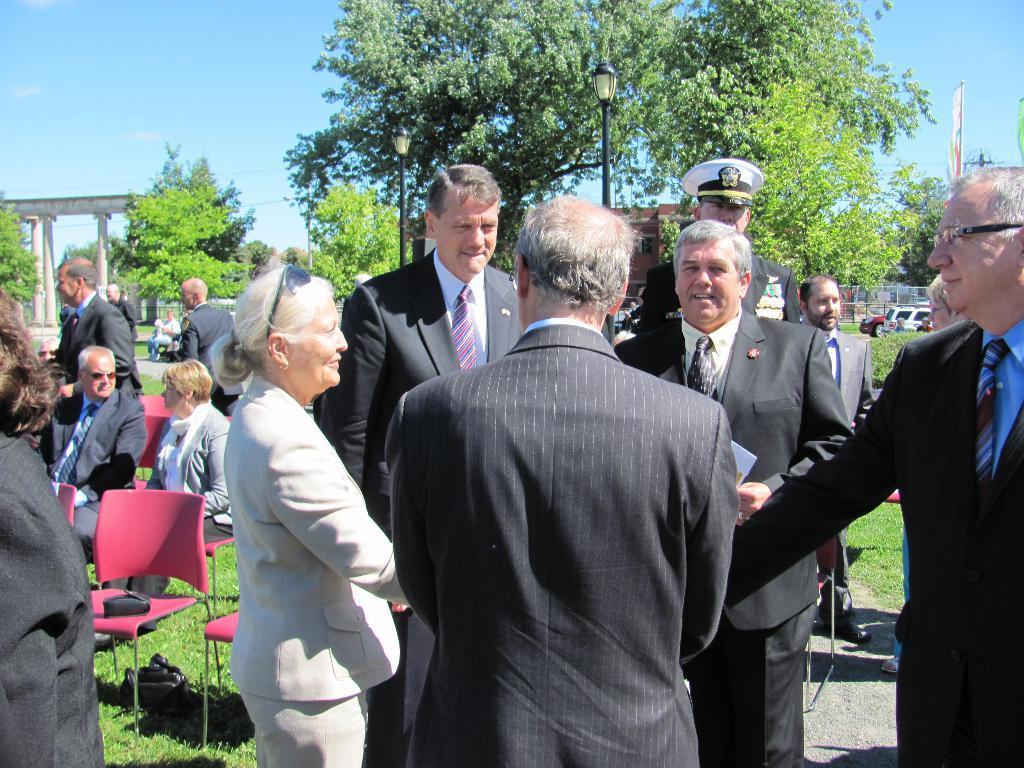In one or two sentences, can you explain what this image depicts? In this picture we can see some people are standing, on the left side there are two persons sitting on chairs, we can see grass at the bottom, we can see poles, trees, vehicles and a hoarding in the middle, on the left side we can see an arch, there is the sky at the top of the picture. 